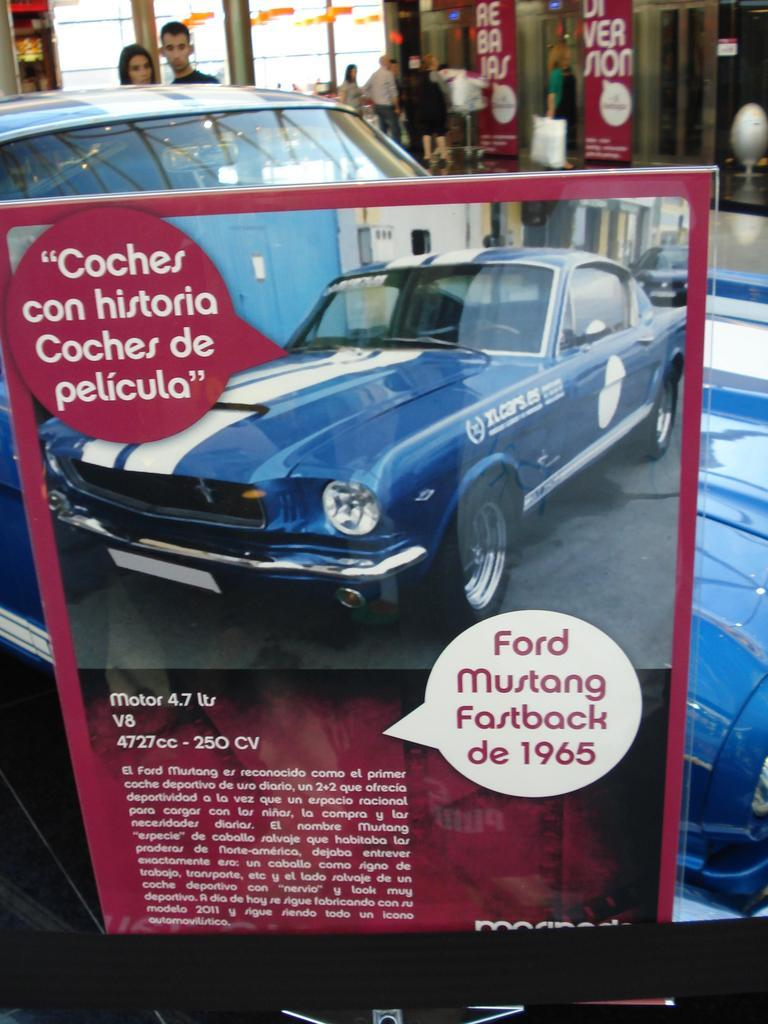What is the main subject in the center of the image? There is a book in the center of the image. What can be seen in the background of the image? In the background of the image, there is a car, advertisements, persons, pillars, and elevators. How many different elements can be seen in the background of the image? There are six different elements visible in the background of the image: a car, advertisements, persons, pillars, and elevators. How many bikes are hanging from the nest in the image? There is no nest or bikes present in the image. What type of fork can be seen in the image? There is no fork present in the image. 